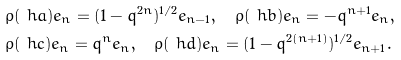<formula> <loc_0><loc_0><loc_500><loc_500>& \rho ( \ h a ) e _ { n } = ( 1 - q ^ { 2 n } ) ^ { 1 / 2 } e _ { n - 1 } , \quad \rho ( \ h b ) e _ { n } = - q ^ { n + 1 } e _ { n } , \\ & \rho ( \ h c ) e _ { n } = q ^ { n } e _ { n } , \quad \rho ( \ h d ) e _ { n } = ( 1 - q ^ { 2 ( n + 1 ) } ) ^ { 1 / 2 } e _ { n + 1 } .</formula> 